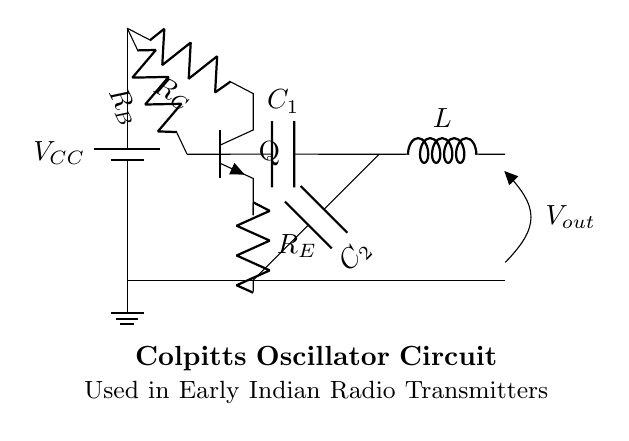what type of transistor is used in this circuit? The circuit shows an npn transistor, as indicated by the notation "Q" with the "npn" label next to it.
Answer: npn what is the function of capacitor C1? Capacitor C1 is part of the feedback network in the oscillator circuit, which helps to determine the frequency of oscillation. It connects to the base of the transistor to provide the necessary feedback for oscillation.
Answer: feedback network how many resistors are in the circuit? The diagram contains three resistors labeled as R_C, R_B, and R_E, indicating that there are three resistors present in the circuit.
Answer: three what is the purpose of the inductor L? The inductor L is used in conjunction with the capacitors to form a resonant tank circuit, which is essential for generating oscillations at a specific frequency.
Answer: resonance what connections are made at the transistor’s base? The base of the transistor is connected to resistor R_B and capacitor C1, indicating both power input and feedback paths.
Answer: R_B and C1 what is the output voltage of the circuit? The output voltage is labeled as V_out on the circuit diagram, which is the voltage across the output terminals at the inductor.
Answer: V_out what type of oscillator is represented in this circuit? The oscillator represented is a Colpitts oscillator, characterized by its use of both capacitors and an inductor for generating oscillations.
Answer: Colpitts 